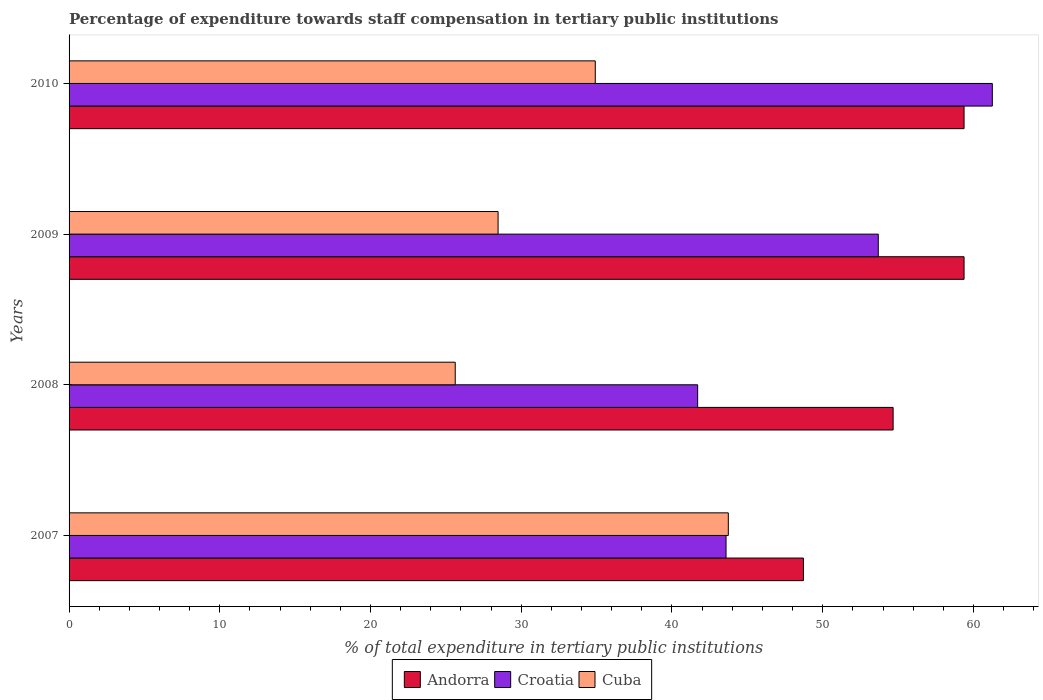Are the number of bars on each tick of the Y-axis equal?
Your response must be concise. Yes. What is the label of the 2nd group of bars from the top?
Your answer should be very brief. 2009. In how many cases, is the number of bars for a given year not equal to the number of legend labels?
Provide a succinct answer. 0. What is the percentage of expenditure towards staff compensation in Andorra in 2008?
Your response must be concise. 54.67. Across all years, what is the maximum percentage of expenditure towards staff compensation in Croatia?
Your answer should be very brief. 61.25. Across all years, what is the minimum percentage of expenditure towards staff compensation in Andorra?
Offer a terse response. 48.72. In which year was the percentage of expenditure towards staff compensation in Cuba minimum?
Keep it short and to the point. 2008. What is the total percentage of expenditure towards staff compensation in Andorra in the graph?
Ensure brevity in your answer.  222.15. What is the difference between the percentage of expenditure towards staff compensation in Andorra in 2007 and that in 2010?
Make the answer very short. -10.66. What is the difference between the percentage of expenditure towards staff compensation in Cuba in 2010 and the percentage of expenditure towards staff compensation in Croatia in 2007?
Provide a short and direct response. -8.68. What is the average percentage of expenditure towards staff compensation in Croatia per year?
Provide a succinct answer. 50.06. In the year 2010, what is the difference between the percentage of expenditure towards staff compensation in Croatia and percentage of expenditure towards staff compensation in Cuba?
Provide a succinct answer. 26.34. What is the ratio of the percentage of expenditure towards staff compensation in Croatia in 2007 to that in 2010?
Your response must be concise. 0.71. Is the percentage of expenditure towards staff compensation in Cuba in 2008 less than that in 2009?
Provide a succinct answer. Yes. Is the difference between the percentage of expenditure towards staff compensation in Croatia in 2009 and 2010 greater than the difference between the percentage of expenditure towards staff compensation in Cuba in 2009 and 2010?
Offer a terse response. No. What is the difference between the highest and the second highest percentage of expenditure towards staff compensation in Croatia?
Your answer should be very brief. 7.57. What is the difference between the highest and the lowest percentage of expenditure towards staff compensation in Croatia?
Provide a succinct answer. 19.55. Is the sum of the percentage of expenditure towards staff compensation in Croatia in 2007 and 2010 greater than the maximum percentage of expenditure towards staff compensation in Andorra across all years?
Provide a succinct answer. Yes. What does the 2nd bar from the top in 2007 represents?
Offer a terse response. Croatia. What does the 3rd bar from the bottom in 2008 represents?
Provide a succinct answer. Cuba. How many bars are there?
Offer a terse response. 12. Are all the bars in the graph horizontal?
Provide a short and direct response. Yes. How many years are there in the graph?
Your answer should be compact. 4. What is the difference between two consecutive major ticks on the X-axis?
Provide a short and direct response. 10. Does the graph contain any zero values?
Offer a terse response. No. Does the graph contain grids?
Offer a terse response. No. What is the title of the graph?
Your response must be concise. Percentage of expenditure towards staff compensation in tertiary public institutions. What is the label or title of the X-axis?
Ensure brevity in your answer.  % of total expenditure in tertiary public institutions. What is the % of total expenditure in tertiary public institutions in Andorra in 2007?
Keep it short and to the point. 48.72. What is the % of total expenditure in tertiary public institutions of Croatia in 2007?
Offer a terse response. 43.59. What is the % of total expenditure in tertiary public institutions in Cuba in 2007?
Your answer should be very brief. 43.74. What is the % of total expenditure in tertiary public institutions of Andorra in 2008?
Provide a short and direct response. 54.67. What is the % of total expenditure in tertiary public institutions in Croatia in 2008?
Offer a very short reply. 41.7. What is the % of total expenditure in tertiary public institutions in Cuba in 2008?
Offer a terse response. 25.62. What is the % of total expenditure in tertiary public institutions of Andorra in 2009?
Keep it short and to the point. 59.38. What is the % of total expenditure in tertiary public institutions of Croatia in 2009?
Keep it short and to the point. 53.69. What is the % of total expenditure in tertiary public institutions in Cuba in 2009?
Give a very brief answer. 28.46. What is the % of total expenditure in tertiary public institutions of Andorra in 2010?
Your response must be concise. 59.38. What is the % of total expenditure in tertiary public institutions in Croatia in 2010?
Your answer should be compact. 61.25. What is the % of total expenditure in tertiary public institutions of Cuba in 2010?
Provide a succinct answer. 34.91. Across all years, what is the maximum % of total expenditure in tertiary public institutions in Andorra?
Offer a very short reply. 59.38. Across all years, what is the maximum % of total expenditure in tertiary public institutions of Croatia?
Provide a short and direct response. 61.25. Across all years, what is the maximum % of total expenditure in tertiary public institutions in Cuba?
Keep it short and to the point. 43.74. Across all years, what is the minimum % of total expenditure in tertiary public institutions in Andorra?
Your answer should be compact. 48.72. Across all years, what is the minimum % of total expenditure in tertiary public institutions of Croatia?
Your answer should be compact. 41.7. Across all years, what is the minimum % of total expenditure in tertiary public institutions in Cuba?
Offer a terse response. 25.62. What is the total % of total expenditure in tertiary public institutions in Andorra in the graph?
Make the answer very short. 222.15. What is the total % of total expenditure in tertiary public institutions in Croatia in the graph?
Make the answer very short. 200.23. What is the total % of total expenditure in tertiary public institutions in Cuba in the graph?
Offer a terse response. 132.73. What is the difference between the % of total expenditure in tertiary public institutions of Andorra in 2007 and that in 2008?
Provide a short and direct response. -5.95. What is the difference between the % of total expenditure in tertiary public institutions of Croatia in 2007 and that in 2008?
Your answer should be compact. 1.88. What is the difference between the % of total expenditure in tertiary public institutions in Cuba in 2007 and that in 2008?
Make the answer very short. 18.12. What is the difference between the % of total expenditure in tertiary public institutions in Andorra in 2007 and that in 2009?
Make the answer very short. -10.66. What is the difference between the % of total expenditure in tertiary public institutions in Croatia in 2007 and that in 2009?
Ensure brevity in your answer.  -10.1. What is the difference between the % of total expenditure in tertiary public institutions in Cuba in 2007 and that in 2009?
Keep it short and to the point. 15.27. What is the difference between the % of total expenditure in tertiary public institutions of Andorra in 2007 and that in 2010?
Make the answer very short. -10.66. What is the difference between the % of total expenditure in tertiary public institutions of Croatia in 2007 and that in 2010?
Give a very brief answer. -17.67. What is the difference between the % of total expenditure in tertiary public institutions in Cuba in 2007 and that in 2010?
Make the answer very short. 8.83. What is the difference between the % of total expenditure in tertiary public institutions of Andorra in 2008 and that in 2009?
Keep it short and to the point. -4.71. What is the difference between the % of total expenditure in tertiary public institutions of Croatia in 2008 and that in 2009?
Offer a terse response. -11.98. What is the difference between the % of total expenditure in tertiary public institutions in Cuba in 2008 and that in 2009?
Your answer should be very brief. -2.84. What is the difference between the % of total expenditure in tertiary public institutions in Andorra in 2008 and that in 2010?
Keep it short and to the point. -4.71. What is the difference between the % of total expenditure in tertiary public institutions of Croatia in 2008 and that in 2010?
Your answer should be very brief. -19.55. What is the difference between the % of total expenditure in tertiary public institutions in Cuba in 2008 and that in 2010?
Offer a very short reply. -9.29. What is the difference between the % of total expenditure in tertiary public institutions in Andorra in 2009 and that in 2010?
Your answer should be compact. 0. What is the difference between the % of total expenditure in tertiary public institutions of Croatia in 2009 and that in 2010?
Ensure brevity in your answer.  -7.57. What is the difference between the % of total expenditure in tertiary public institutions in Cuba in 2009 and that in 2010?
Give a very brief answer. -6.45. What is the difference between the % of total expenditure in tertiary public institutions in Andorra in 2007 and the % of total expenditure in tertiary public institutions in Croatia in 2008?
Keep it short and to the point. 7.02. What is the difference between the % of total expenditure in tertiary public institutions in Andorra in 2007 and the % of total expenditure in tertiary public institutions in Cuba in 2008?
Make the answer very short. 23.1. What is the difference between the % of total expenditure in tertiary public institutions of Croatia in 2007 and the % of total expenditure in tertiary public institutions of Cuba in 2008?
Provide a short and direct response. 17.97. What is the difference between the % of total expenditure in tertiary public institutions in Andorra in 2007 and the % of total expenditure in tertiary public institutions in Croatia in 2009?
Provide a succinct answer. -4.97. What is the difference between the % of total expenditure in tertiary public institutions in Andorra in 2007 and the % of total expenditure in tertiary public institutions in Cuba in 2009?
Make the answer very short. 20.26. What is the difference between the % of total expenditure in tertiary public institutions of Croatia in 2007 and the % of total expenditure in tertiary public institutions of Cuba in 2009?
Keep it short and to the point. 15.12. What is the difference between the % of total expenditure in tertiary public institutions of Andorra in 2007 and the % of total expenditure in tertiary public institutions of Croatia in 2010?
Keep it short and to the point. -12.53. What is the difference between the % of total expenditure in tertiary public institutions of Andorra in 2007 and the % of total expenditure in tertiary public institutions of Cuba in 2010?
Make the answer very short. 13.81. What is the difference between the % of total expenditure in tertiary public institutions in Croatia in 2007 and the % of total expenditure in tertiary public institutions in Cuba in 2010?
Provide a succinct answer. 8.68. What is the difference between the % of total expenditure in tertiary public institutions of Andorra in 2008 and the % of total expenditure in tertiary public institutions of Cuba in 2009?
Your answer should be very brief. 26.21. What is the difference between the % of total expenditure in tertiary public institutions in Croatia in 2008 and the % of total expenditure in tertiary public institutions in Cuba in 2009?
Keep it short and to the point. 13.24. What is the difference between the % of total expenditure in tertiary public institutions of Andorra in 2008 and the % of total expenditure in tertiary public institutions of Croatia in 2010?
Offer a very short reply. -6.58. What is the difference between the % of total expenditure in tertiary public institutions of Andorra in 2008 and the % of total expenditure in tertiary public institutions of Cuba in 2010?
Offer a terse response. 19.76. What is the difference between the % of total expenditure in tertiary public institutions of Croatia in 2008 and the % of total expenditure in tertiary public institutions of Cuba in 2010?
Provide a short and direct response. 6.79. What is the difference between the % of total expenditure in tertiary public institutions of Andorra in 2009 and the % of total expenditure in tertiary public institutions of Croatia in 2010?
Give a very brief answer. -1.88. What is the difference between the % of total expenditure in tertiary public institutions in Andorra in 2009 and the % of total expenditure in tertiary public institutions in Cuba in 2010?
Offer a terse response. 24.47. What is the difference between the % of total expenditure in tertiary public institutions of Croatia in 2009 and the % of total expenditure in tertiary public institutions of Cuba in 2010?
Offer a terse response. 18.77. What is the average % of total expenditure in tertiary public institutions of Andorra per year?
Keep it short and to the point. 55.54. What is the average % of total expenditure in tertiary public institutions in Croatia per year?
Give a very brief answer. 50.06. What is the average % of total expenditure in tertiary public institutions of Cuba per year?
Make the answer very short. 33.18. In the year 2007, what is the difference between the % of total expenditure in tertiary public institutions in Andorra and % of total expenditure in tertiary public institutions in Croatia?
Offer a terse response. 5.13. In the year 2007, what is the difference between the % of total expenditure in tertiary public institutions of Andorra and % of total expenditure in tertiary public institutions of Cuba?
Ensure brevity in your answer.  4.98. In the year 2007, what is the difference between the % of total expenditure in tertiary public institutions of Croatia and % of total expenditure in tertiary public institutions of Cuba?
Make the answer very short. -0.15. In the year 2008, what is the difference between the % of total expenditure in tertiary public institutions in Andorra and % of total expenditure in tertiary public institutions in Croatia?
Make the answer very short. 12.97. In the year 2008, what is the difference between the % of total expenditure in tertiary public institutions in Andorra and % of total expenditure in tertiary public institutions in Cuba?
Provide a short and direct response. 29.05. In the year 2008, what is the difference between the % of total expenditure in tertiary public institutions in Croatia and % of total expenditure in tertiary public institutions in Cuba?
Your answer should be very brief. 16.08. In the year 2009, what is the difference between the % of total expenditure in tertiary public institutions in Andorra and % of total expenditure in tertiary public institutions in Croatia?
Your answer should be compact. 5.69. In the year 2009, what is the difference between the % of total expenditure in tertiary public institutions in Andorra and % of total expenditure in tertiary public institutions in Cuba?
Offer a very short reply. 30.92. In the year 2009, what is the difference between the % of total expenditure in tertiary public institutions in Croatia and % of total expenditure in tertiary public institutions in Cuba?
Your answer should be very brief. 25.22. In the year 2010, what is the difference between the % of total expenditure in tertiary public institutions in Andorra and % of total expenditure in tertiary public institutions in Croatia?
Your answer should be very brief. -1.88. In the year 2010, what is the difference between the % of total expenditure in tertiary public institutions of Andorra and % of total expenditure in tertiary public institutions of Cuba?
Ensure brevity in your answer.  24.47. In the year 2010, what is the difference between the % of total expenditure in tertiary public institutions in Croatia and % of total expenditure in tertiary public institutions in Cuba?
Give a very brief answer. 26.34. What is the ratio of the % of total expenditure in tertiary public institutions in Andorra in 2007 to that in 2008?
Keep it short and to the point. 0.89. What is the ratio of the % of total expenditure in tertiary public institutions in Croatia in 2007 to that in 2008?
Your answer should be very brief. 1.05. What is the ratio of the % of total expenditure in tertiary public institutions in Cuba in 2007 to that in 2008?
Ensure brevity in your answer.  1.71. What is the ratio of the % of total expenditure in tertiary public institutions of Andorra in 2007 to that in 2009?
Provide a succinct answer. 0.82. What is the ratio of the % of total expenditure in tertiary public institutions in Croatia in 2007 to that in 2009?
Offer a terse response. 0.81. What is the ratio of the % of total expenditure in tertiary public institutions of Cuba in 2007 to that in 2009?
Ensure brevity in your answer.  1.54. What is the ratio of the % of total expenditure in tertiary public institutions in Andorra in 2007 to that in 2010?
Offer a terse response. 0.82. What is the ratio of the % of total expenditure in tertiary public institutions in Croatia in 2007 to that in 2010?
Offer a very short reply. 0.71. What is the ratio of the % of total expenditure in tertiary public institutions of Cuba in 2007 to that in 2010?
Your answer should be compact. 1.25. What is the ratio of the % of total expenditure in tertiary public institutions of Andorra in 2008 to that in 2009?
Make the answer very short. 0.92. What is the ratio of the % of total expenditure in tertiary public institutions of Croatia in 2008 to that in 2009?
Keep it short and to the point. 0.78. What is the ratio of the % of total expenditure in tertiary public institutions of Cuba in 2008 to that in 2009?
Your response must be concise. 0.9. What is the ratio of the % of total expenditure in tertiary public institutions of Andorra in 2008 to that in 2010?
Offer a terse response. 0.92. What is the ratio of the % of total expenditure in tertiary public institutions of Croatia in 2008 to that in 2010?
Your answer should be compact. 0.68. What is the ratio of the % of total expenditure in tertiary public institutions in Cuba in 2008 to that in 2010?
Provide a short and direct response. 0.73. What is the ratio of the % of total expenditure in tertiary public institutions in Andorra in 2009 to that in 2010?
Your answer should be very brief. 1. What is the ratio of the % of total expenditure in tertiary public institutions of Croatia in 2009 to that in 2010?
Offer a terse response. 0.88. What is the ratio of the % of total expenditure in tertiary public institutions of Cuba in 2009 to that in 2010?
Offer a terse response. 0.82. What is the difference between the highest and the second highest % of total expenditure in tertiary public institutions in Andorra?
Your answer should be compact. 0. What is the difference between the highest and the second highest % of total expenditure in tertiary public institutions in Croatia?
Your answer should be very brief. 7.57. What is the difference between the highest and the second highest % of total expenditure in tertiary public institutions in Cuba?
Provide a short and direct response. 8.83. What is the difference between the highest and the lowest % of total expenditure in tertiary public institutions in Andorra?
Make the answer very short. 10.66. What is the difference between the highest and the lowest % of total expenditure in tertiary public institutions of Croatia?
Your response must be concise. 19.55. What is the difference between the highest and the lowest % of total expenditure in tertiary public institutions of Cuba?
Your response must be concise. 18.12. 